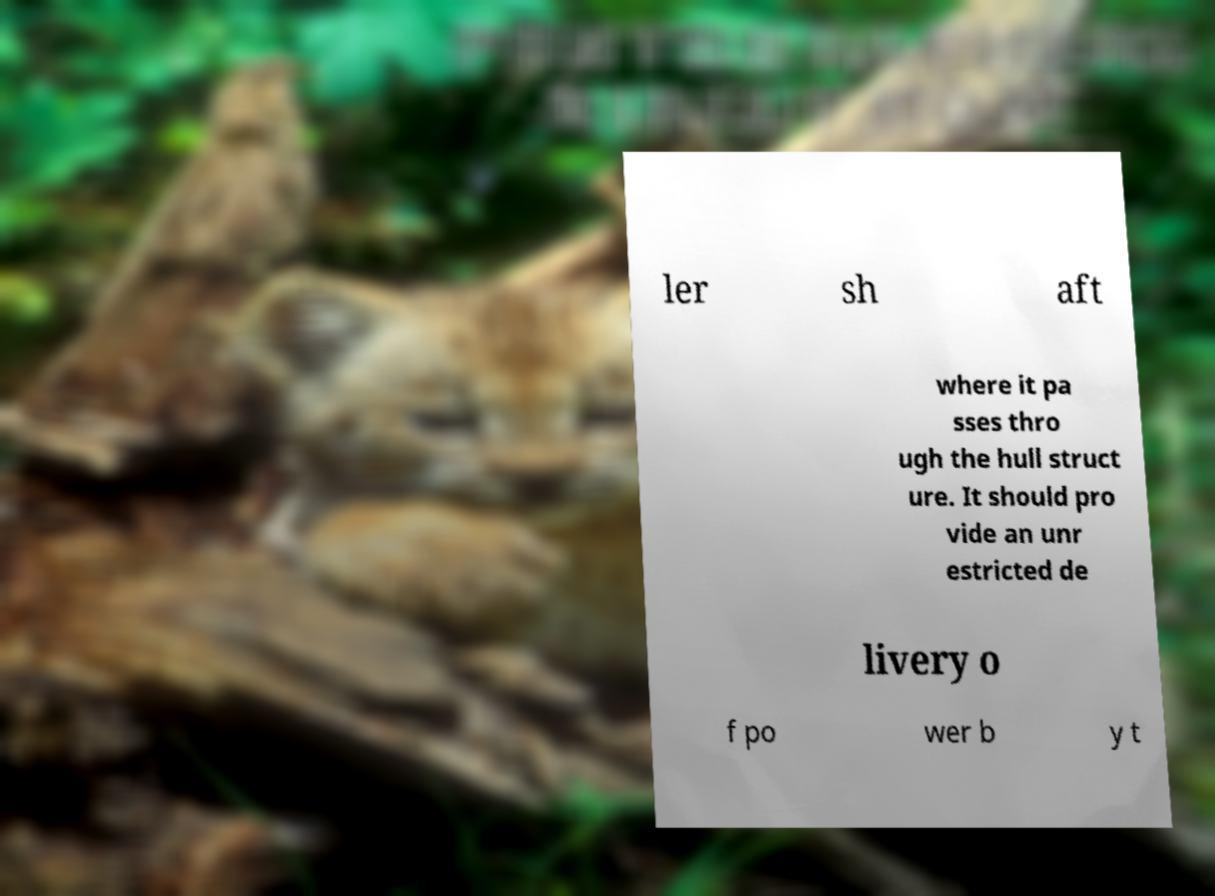Please read and relay the text visible in this image. What does it say? ler sh aft where it pa sses thro ugh the hull struct ure. It should pro vide an unr estricted de livery o f po wer b y t 